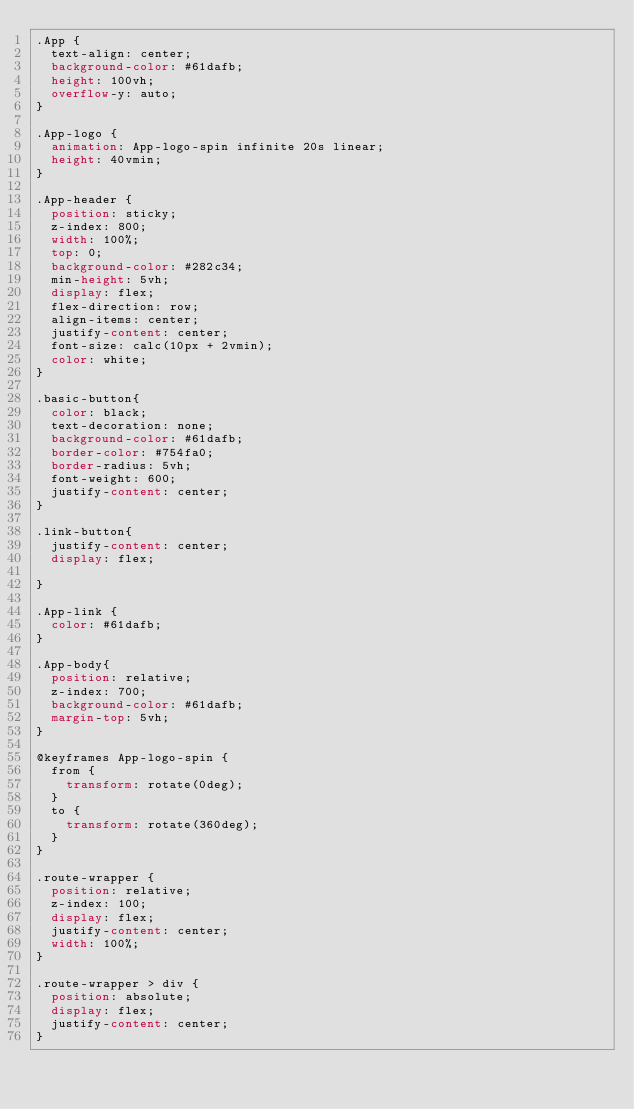Convert code to text. <code><loc_0><loc_0><loc_500><loc_500><_CSS_>.App {
  text-align: center;
  background-color: #61dafb;
  height: 100vh;
  overflow-y: auto;
}

.App-logo {
  animation: App-logo-spin infinite 20s linear;
  height: 40vmin;
}

.App-header {
  position: sticky;
  z-index: 800;
  width: 100%;
  top: 0;
  background-color: #282c34;
  min-height: 5vh;
  display: flex;
  flex-direction: row;
  align-items: center;
  justify-content: center;
  font-size: calc(10px + 2vmin);
  color: white;
}

.basic-button{
  color: black;
  text-decoration: none;
  background-color: #61dafb;
  border-color: #754fa0;
  border-radius: 5vh;
  font-weight: 600;
  justify-content: center;
}

.link-button{
  justify-content: center;
  display: flex;

}

.App-link {
  color: #61dafb;
}

.App-body{
  position: relative;
  z-index: 700;
  background-color: #61dafb;
  margin-top: 5vh;
}

@keyframes App-logo-spin {
  from {
    transform: rotate(0deg);
  }
  to {
    transform: rotate(360deg);
  }
}

.route-wrapper {
  position: relative;
  z-index: 100;
  display: flex;
  justify-content: center;
  width: 100%;
}

.route-wrapper > div {
  position: absolute;
  display: flex;
  justify-content: center;
}
</code> 